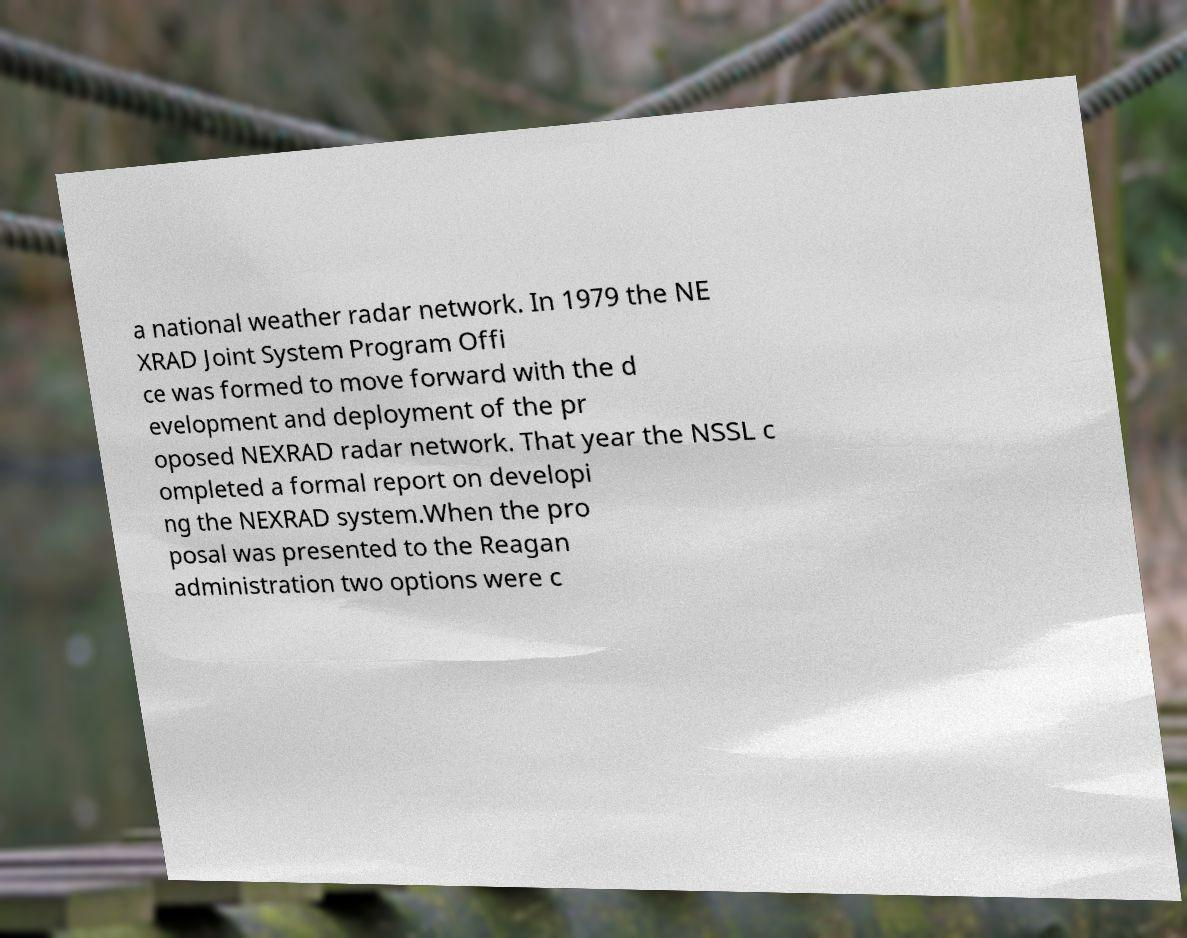Could you assist in decoding the text presented in this image and type it out clearly? a national weather radar network. In 1979 the NE XRAD Joint System Program Offi ce was formed to move forward with the d evelopment and deployment of the pr oposed NEXRAD radar network. That year the NSSL c ompleted a formal report on developi ng the NEXRAD system.When the pro posal was presented to the Reagan administration two options were c 